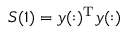Convert formula to latex. <formula><loc_0><loc_0><loc_500><loc_500>S ( 1 ) = y ( \colon ) ^ { T } y ( \colon )</formula> 